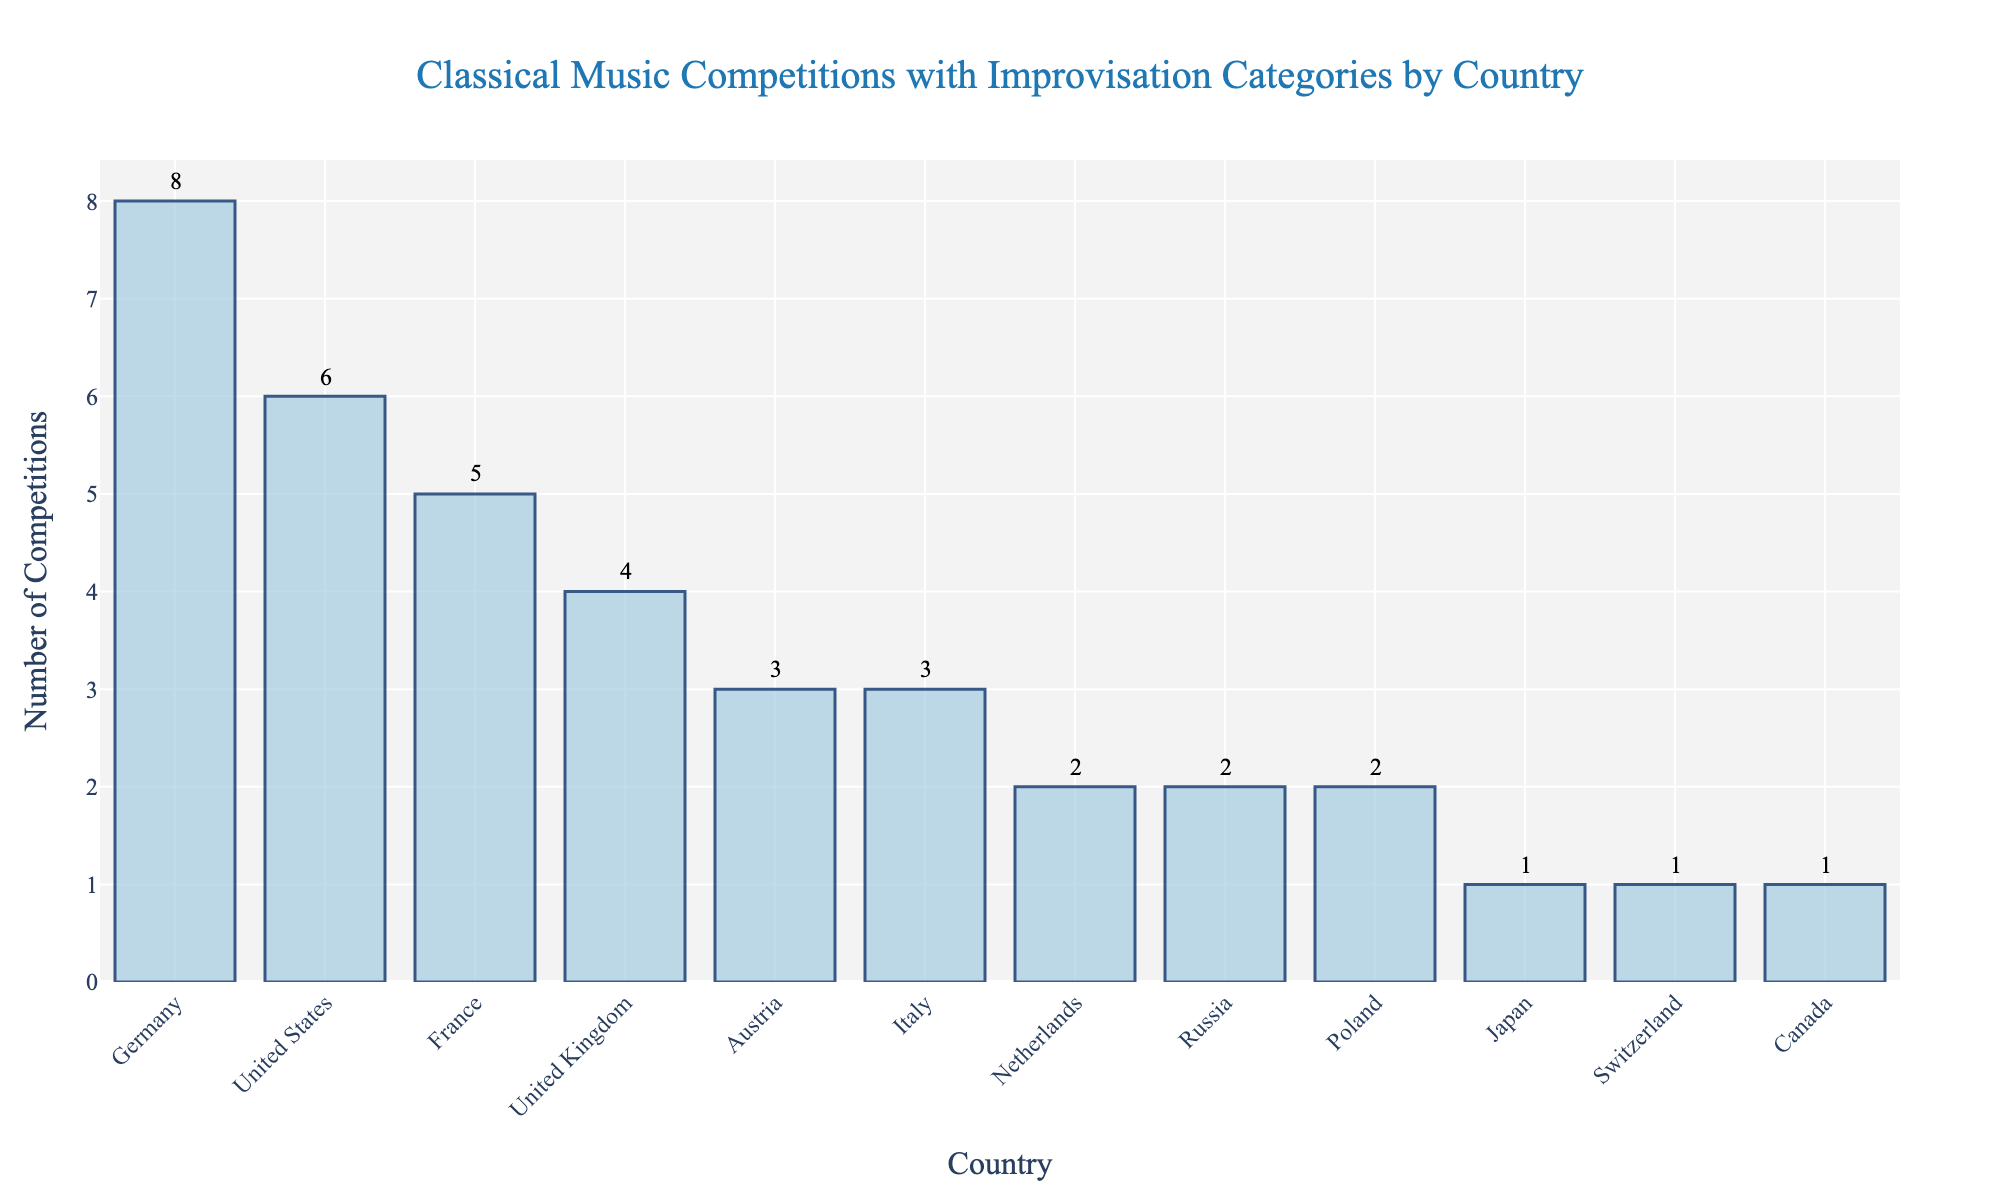Which country has the highest number of classical music competitions featuring improvisation categories? Look at the bar with the greatest height in the chart. This will indicate the country with the highest number of competitions featuring improvisation categories.
Answer: Germany Which two countries have the same number of classical music competitions featuring improvisation categories? Look for bars that are of the same height. These bars represent countries with the same number of competitions.
Answer: Italy and Austria; Netherlands and Russia; Poland and Russia Which countries have more than 3 classical music competitions featuring improvisation categories? Identify the bars that have a value greater than 3 on the y-axis. List the corresponding countries.
Answer: Germany, United States, France, United Kingdom What is the total number of classical music competitions featuring improvisation categories for Germany and the United States together? Add the number of competitions for Germany and the United States together. Germany has 8 and the United States has 6. So, 8 + 6 = 14.
Answer: 14 How many more competitions featuring improvisation categories does Germany have compared to France? Subtract the number of competitions France has from the number Germany has. Germany has 8, France has 5. Thus, 8 - 5 = 3.
Answer: 3 Which country has the least number of classical music competitions featuring improvisation categories? Identify the bar with the shortest height. This represents the country with the least number of competitions.
Answer: Japan, Switzerland, Canada (each with 1) How many countries have exactly 2 classical music competitions featuring improvisation categories? Count the number of bars with a height corresponding to 2 competitions. There are three such bars.
Answer: 3 Is the bar for the United Kingdom taller, shorter, or the same height as the bar for France? Compare the heights of the bars for the United Kingdom and France. The bar for the United Kingdom is shorter than the bar for France.
Answer: Shorter What is the average number of classical music competitions featuring improvisation categories across all the countries listed? Add up all the competitions and divide by the number of countries. The total number is 38, and there are 12 countries. 38 / 12 = 3.17.
Answer: 3.17 By how much does Austria exceed Japan in terms of the number of classical music competitions featuring improvisation categories? Subtract the number of competitions Japan has from the number Austria has. Austria has 3, Japan has 1. Thus, 3 - 1 = 2.
Answer: 2 